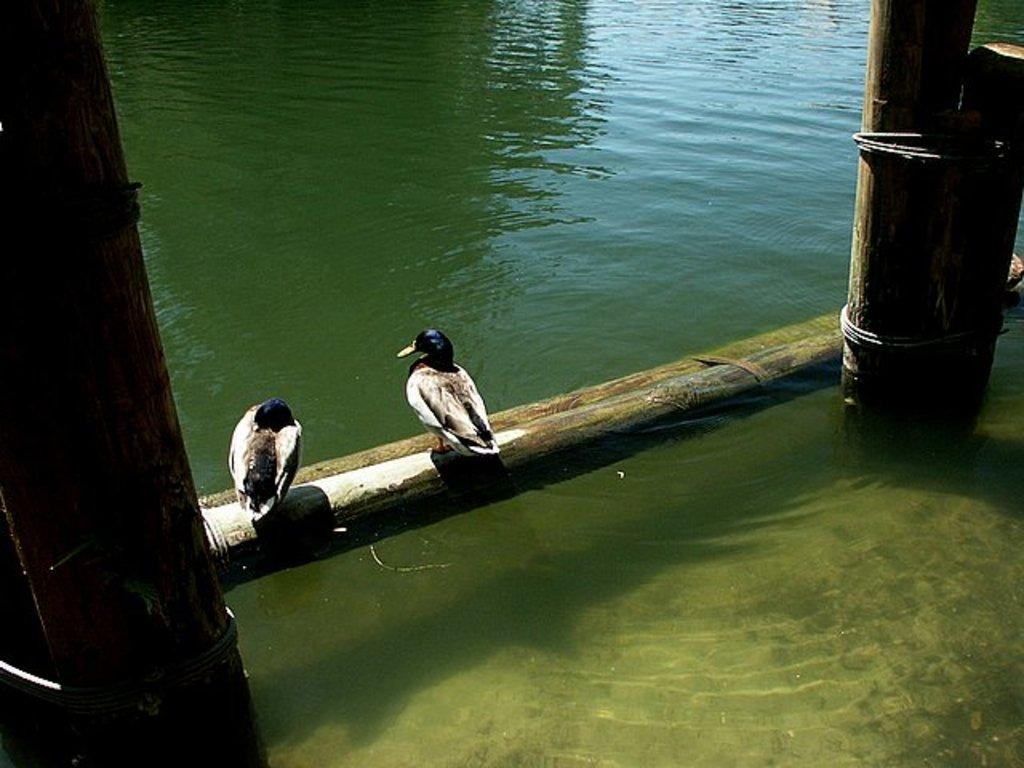What is the primary element visible in the image? There is water in the image. Are there any structures or objects in the water? Yes, there are wooden poles in the water. What can be seen on top of the wooden poles? There are two birds on the wooden poles. How does the clam contribute to the stability of the wooden poles in the image? There are no clams present in the image, so their contribution to the stability of the wooden poles cannot be determined. 